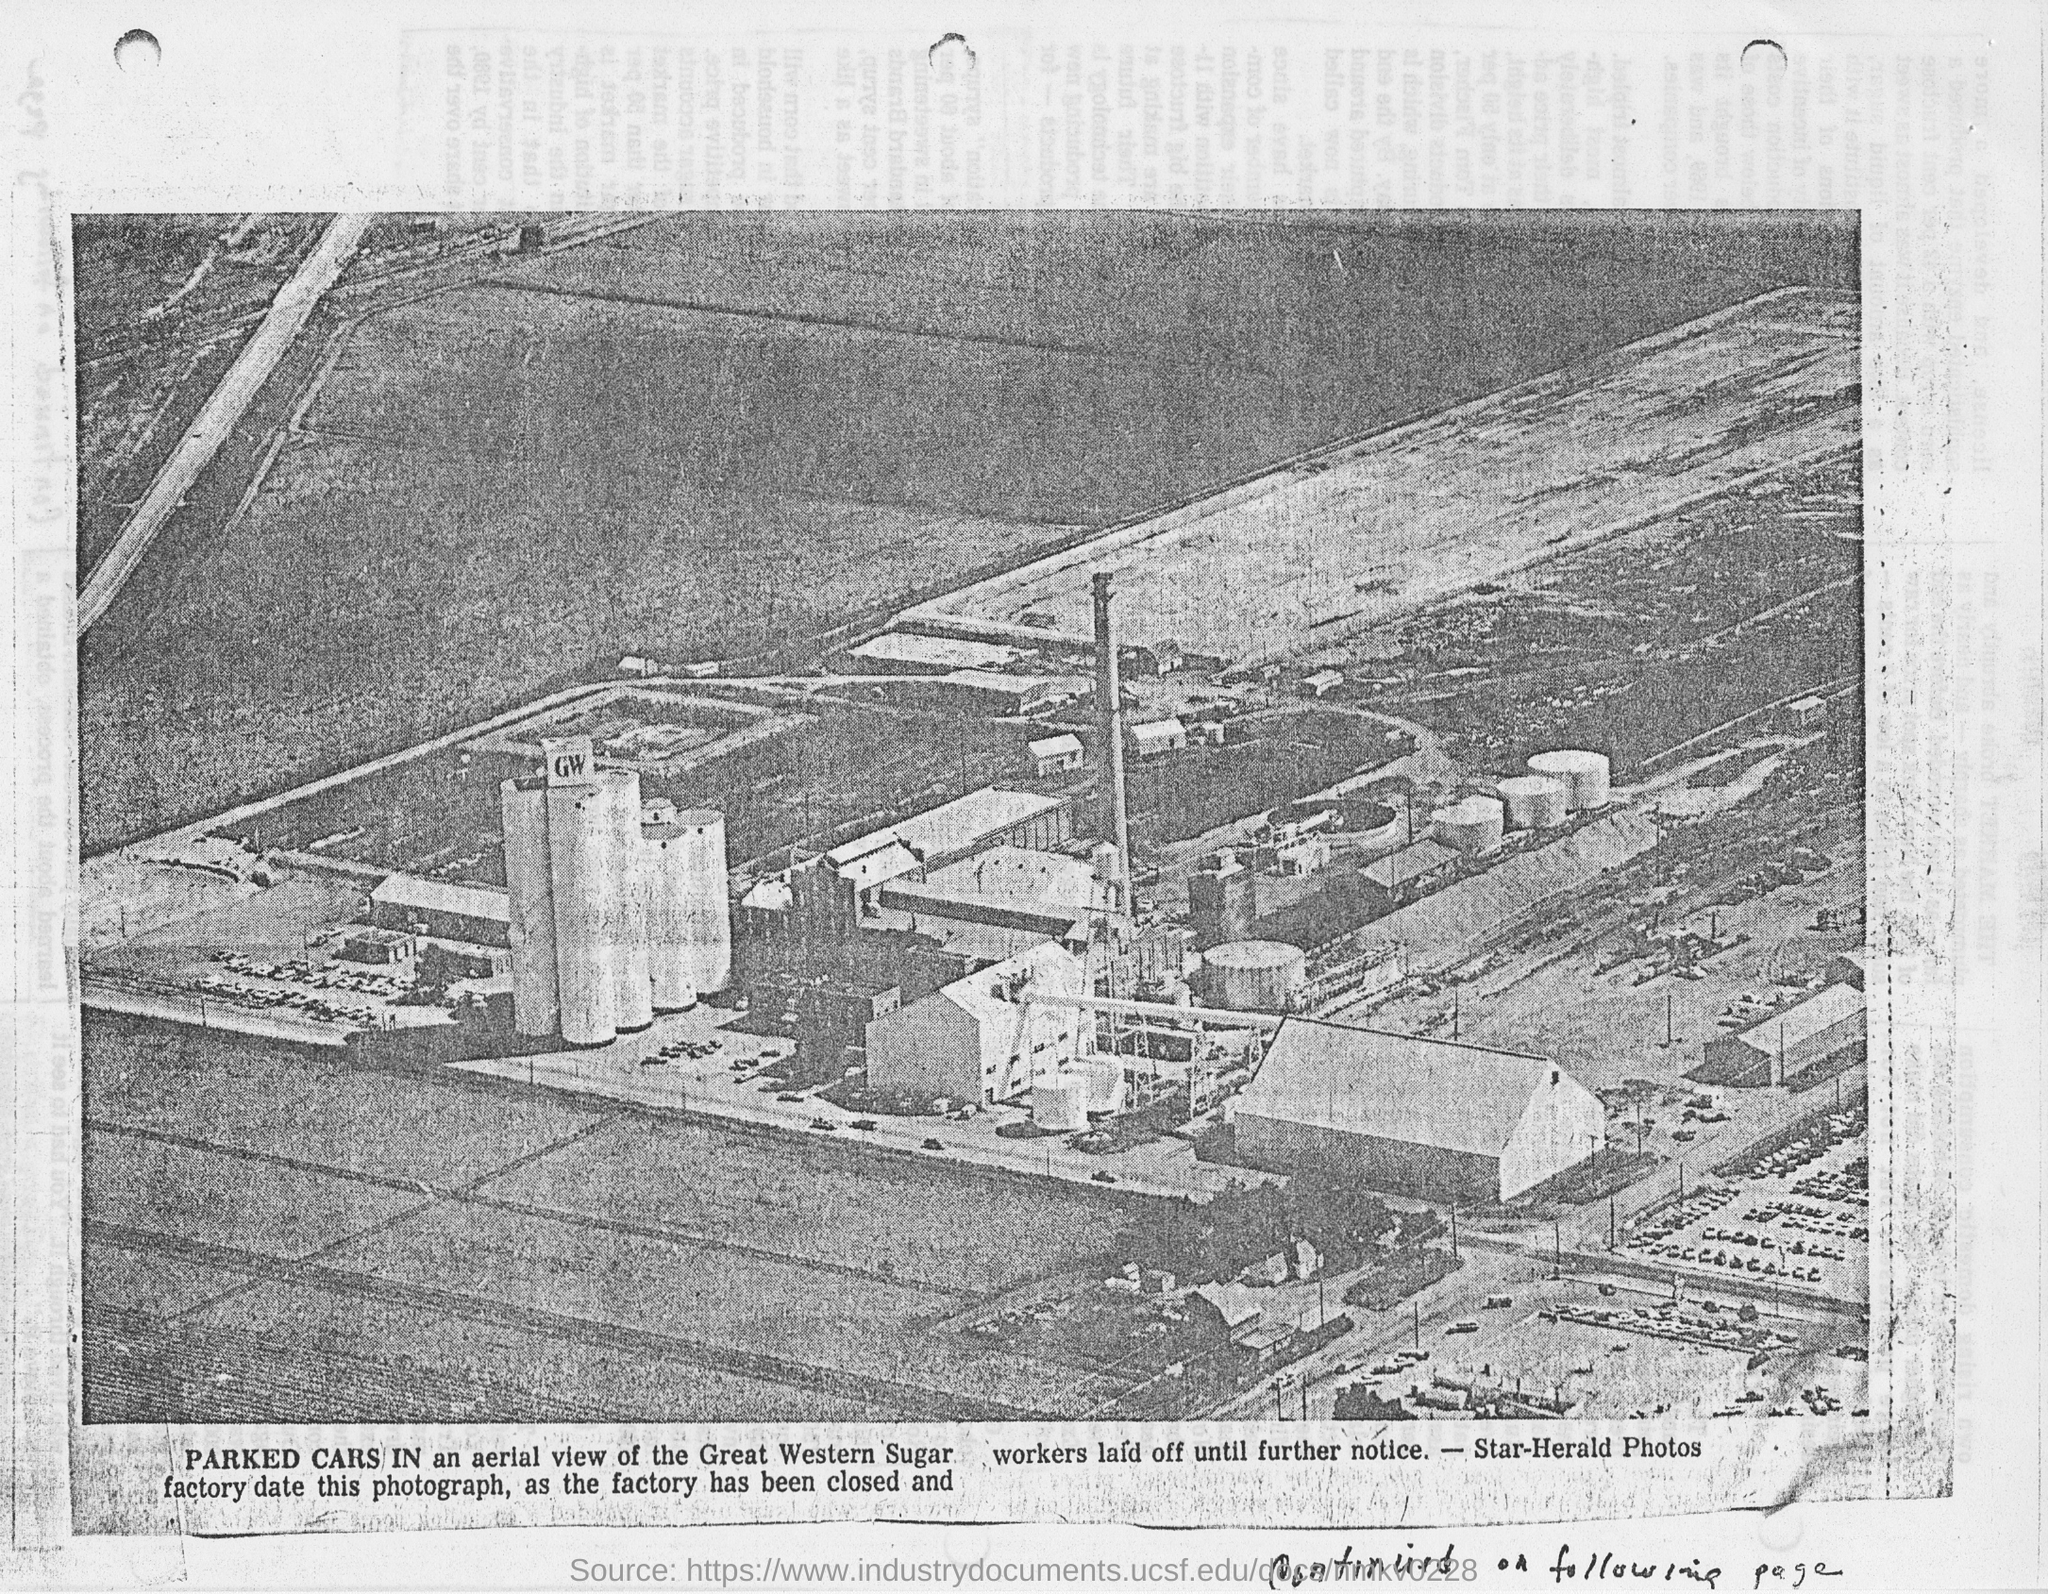The photo has the aerial view of which company?
Ensure brevity in your answer.  The Great Western Sugar. 